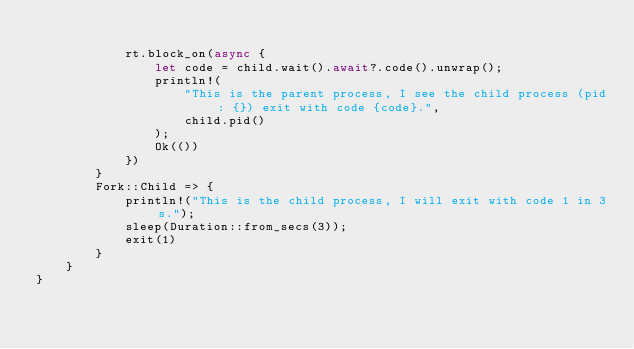Convert code to text. <code><loc_0><loc_0><loc_500><loc_500><_Rust_>
            rt.block_on(async {
                let code = child.wait().await?.code().unwrap();
                println!(
                    "This is the parent process, I see the child process (pid: {}) exit with code {code}.",
                    child.pid()
                );
                Ok(())
            })
        }
        Fork::Child => {
            println!("This is the child process, I will exit with code 1 in 3s.");
            sleep(Duration::from_secs(3));
            exit(1)
        }
    }
}
</code> 